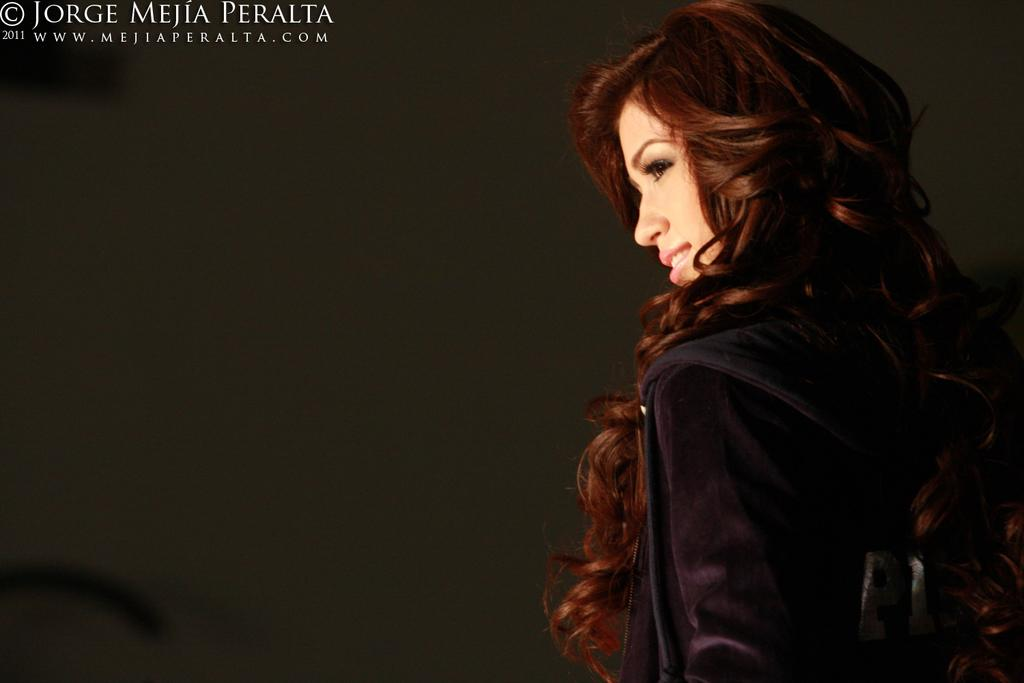What is located on the right side of the image? There is a woman on the right side of the image. What can be seen at the top left corner of the image? There is text at the top left corner of the image. Can you see any mountains in the image? There are no mountains present in the image. What type of show is the woman performing in the image? There is no show or performance depicted in the image; it only features a woman and text. 